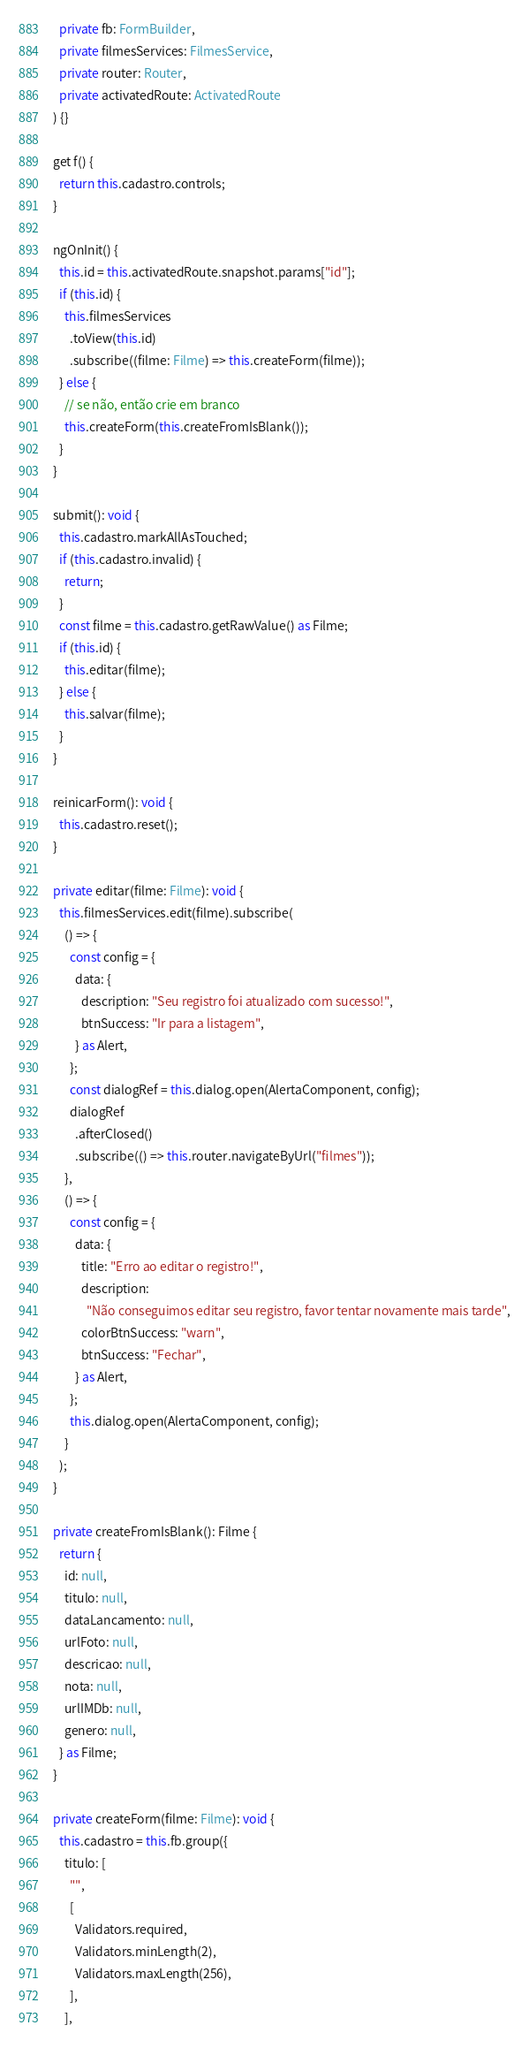Convert code to text. <code><loc_0><loc_0><loc_500><loc_500><_TypeScript_>    private fb: FormBuilder,
    private filmesServices: FilmesService,
    private router: Router,
    private activatedRoute: ActivatedRoute
  ) {}

  get f() {
    return this.cadastro.controls;
  }

  ngOnInit() {
    this.id = this.activatedRoute.snapshot.params["id"];
    if (this.id) {
      this.filmesServices
        .toView(this.id)
        .subscribe((filme: Filme) => this.createForm(filme));
    } else {
      // se não, então crie em branco
      this.createForm(this.createFromIsBlank());
    }
  }

  submit(): void {
    this.cadastro.markAllAsTouched;
    if (this.cadastro.invalid) {
      return;
    }
    const filme = this.cadastro.getRawValue() as Filme;
    if (this.id) {
      this.editar(filme);
    } else {
      this.salvar(filme);
    }
  }

  reinicarForm(): void {
    this.cadastro.reset();
  }

  private editar(filme: Filme): void {
    this.filmesServices.edit(filme).subscribe(
      () => {
        const config = {
          data: {
            description: "Seu registro foi atualizado com sucesso!",
            btnSuccess: "Ir para a listagem",
          } as Alert,
        };
        const dialogRef = this.dialog.open(AlertaComponent, config);
        dialogRef
          .afterClosed()
          .subscribe(() => this.router.navigateByUrl("filmes"));
      },
      () => {
        const config = {
          data: {
            title: "Erro ao editar o registro!",
            description:
              "Não conseguimos editar seu registro, favor tentar novamente mais tarde",
            colorBtnSuccess: "warn",
            btnSuccess: "Fechar",
          } as Alert,
        };
        this.dialog.open(AlertaComponent, config);
      }
    );
  }

  private createFromIsBlank(): Filme {
    return {
      id: null,
      titulo: null,
      dataLancamento: null,
      urlFoto: null,
      descricao: null,
      nota: null,
      urlIMDb: null,
      genero: null,
    } as Filme;
  }

  private createForm(filme: Filme): void {
    this.cadastro = this.fb.group({
      titulo: [
        "",
        [
          Validators.required,
          Validators.minLength(2),
          Validators.maxLength(256),
        ],
      ],</code> 